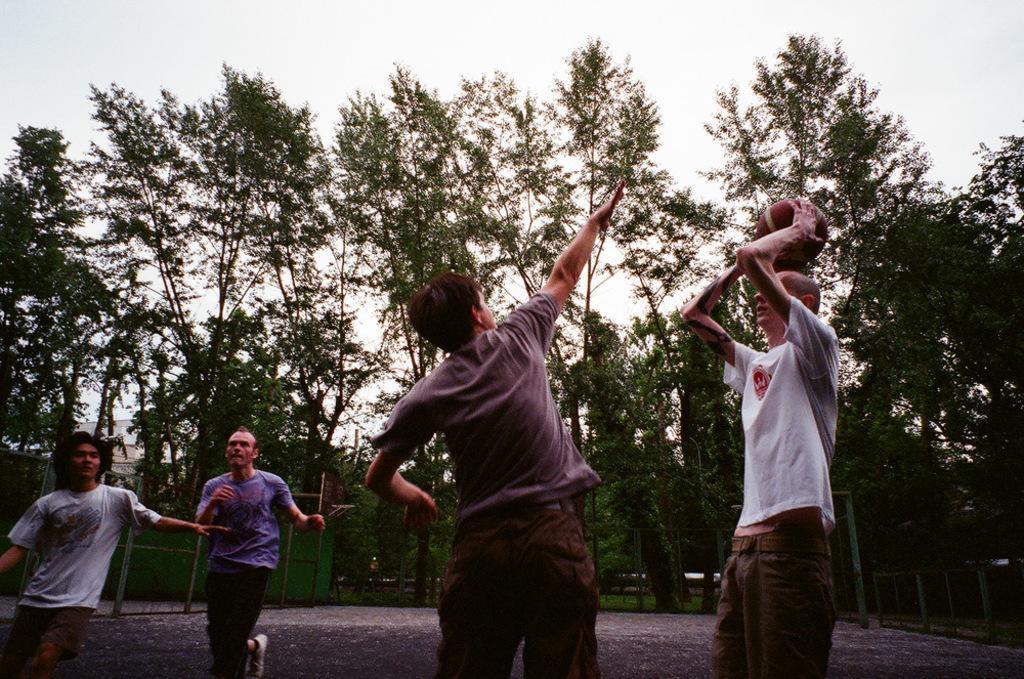Describe this image in one or two sentences. In this image we can see trees, people, fence, ball and sky. 